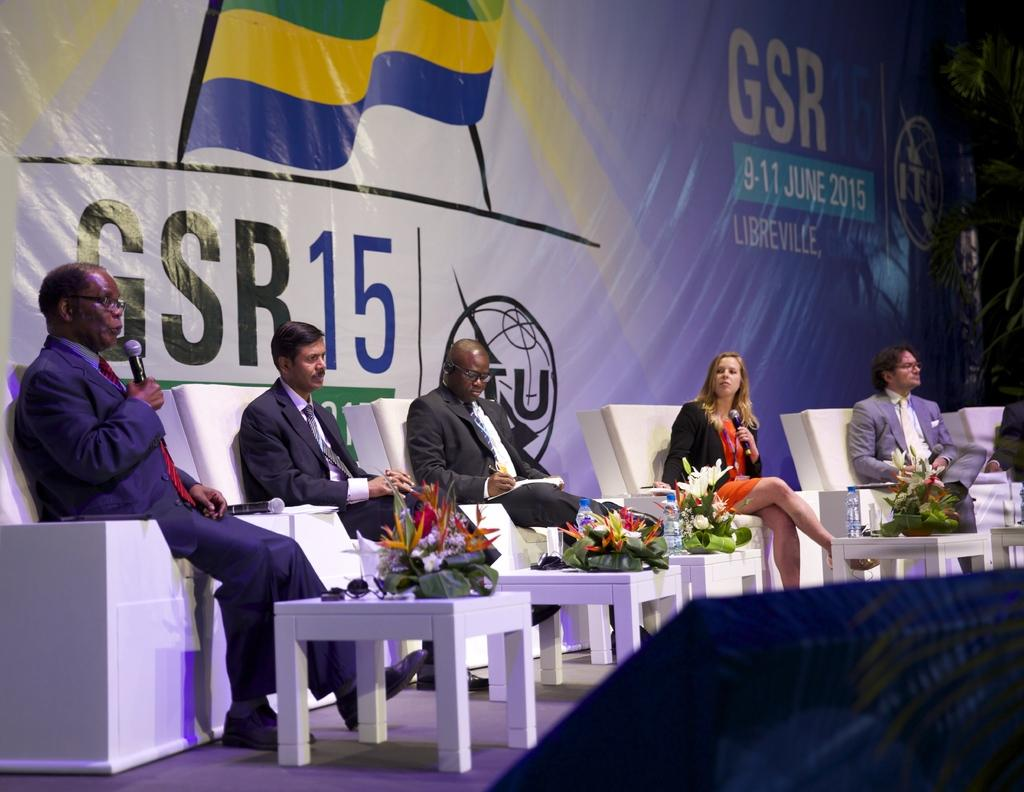What are the people in the image doing? The persons in the image are sitting on chairs. What is located in the center of the image? There is a table in the image. What decorative items can be seen on the table? There are flower bouquets on the table. What else is present on the table? There is a bottle on the table. What can be seen in the background of the image? There is a banner visible in the background of the image. What type of alley can be seen behind the banner in the image? There is no alley present in the image; it only shows a banner in the background. 